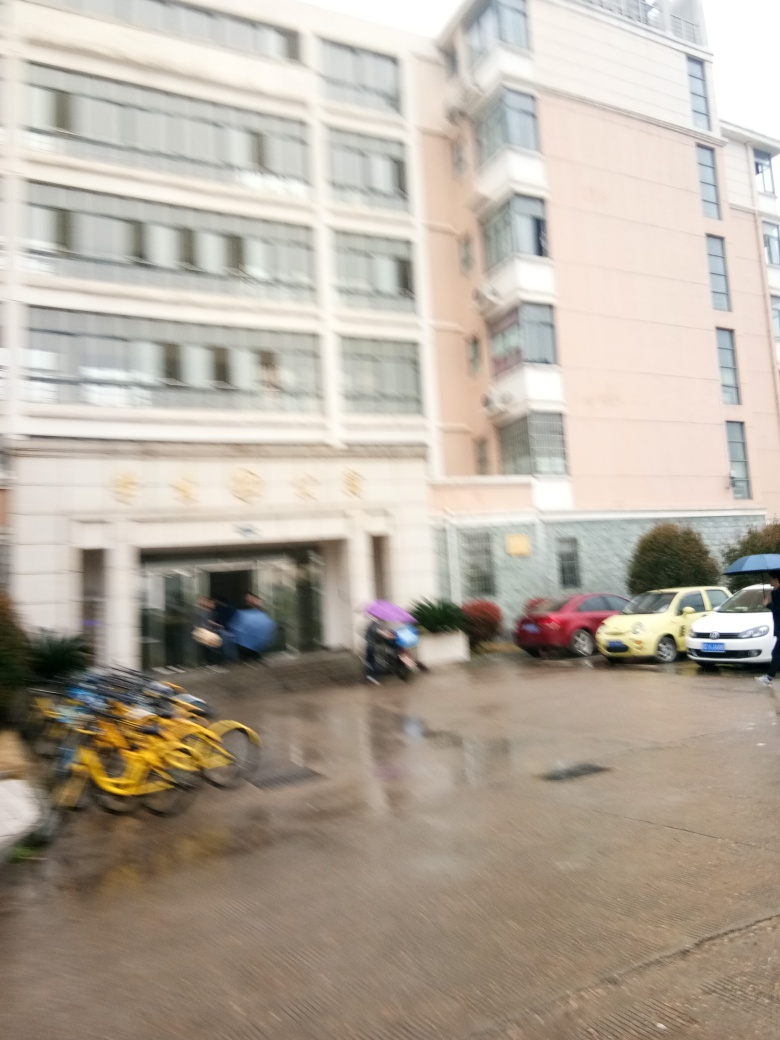What might be the reasons for the presence of bicycles and cars in this setting? The presence of bicycles and cars suggests this is a multi-purpose area likely used for both parking and bicycle storage, indicating a functional space adjacent to what could be a residential or commercial building. Such a combination of vehicles and bicycles is common in urban areas where space is shared between various modes of transportation. 